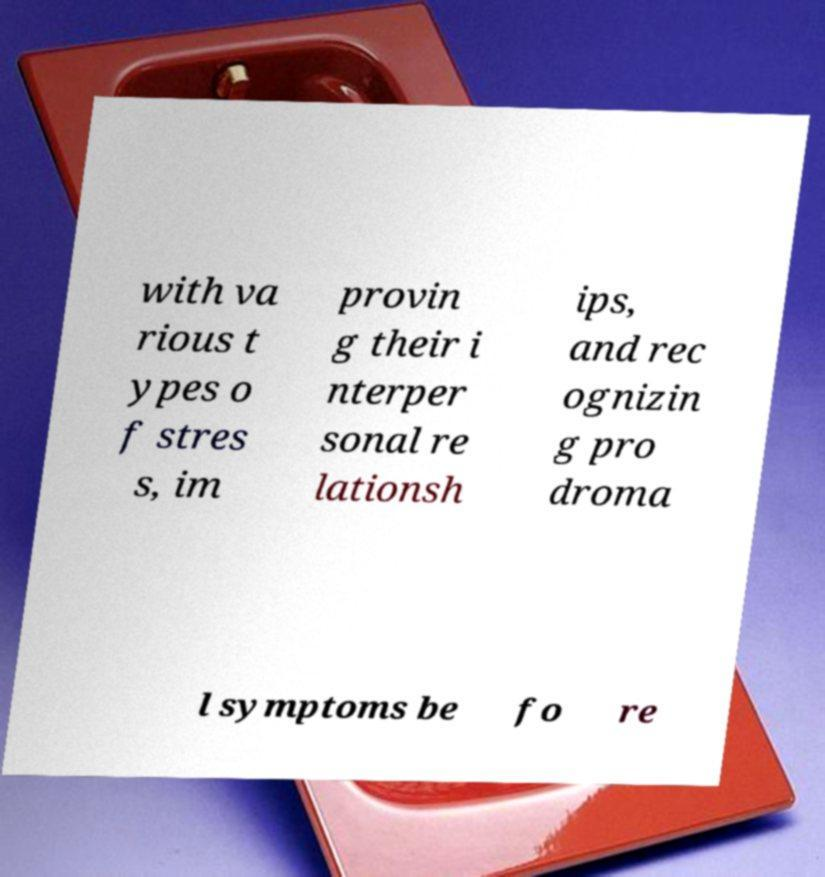Could you assist in decoding the text presented in this image and type it out clearly? with va rious t ypes o f stres s, im provin g their i nterper sonal re lationsh ips, and rec ognizin g pro droma l symptoms be fo re 